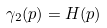Convert formula to latex. <formula><loc_0><loc_0><loc_500><loc_500>\gamma _ { 2 } ( p ) = H ( p )</formula> 